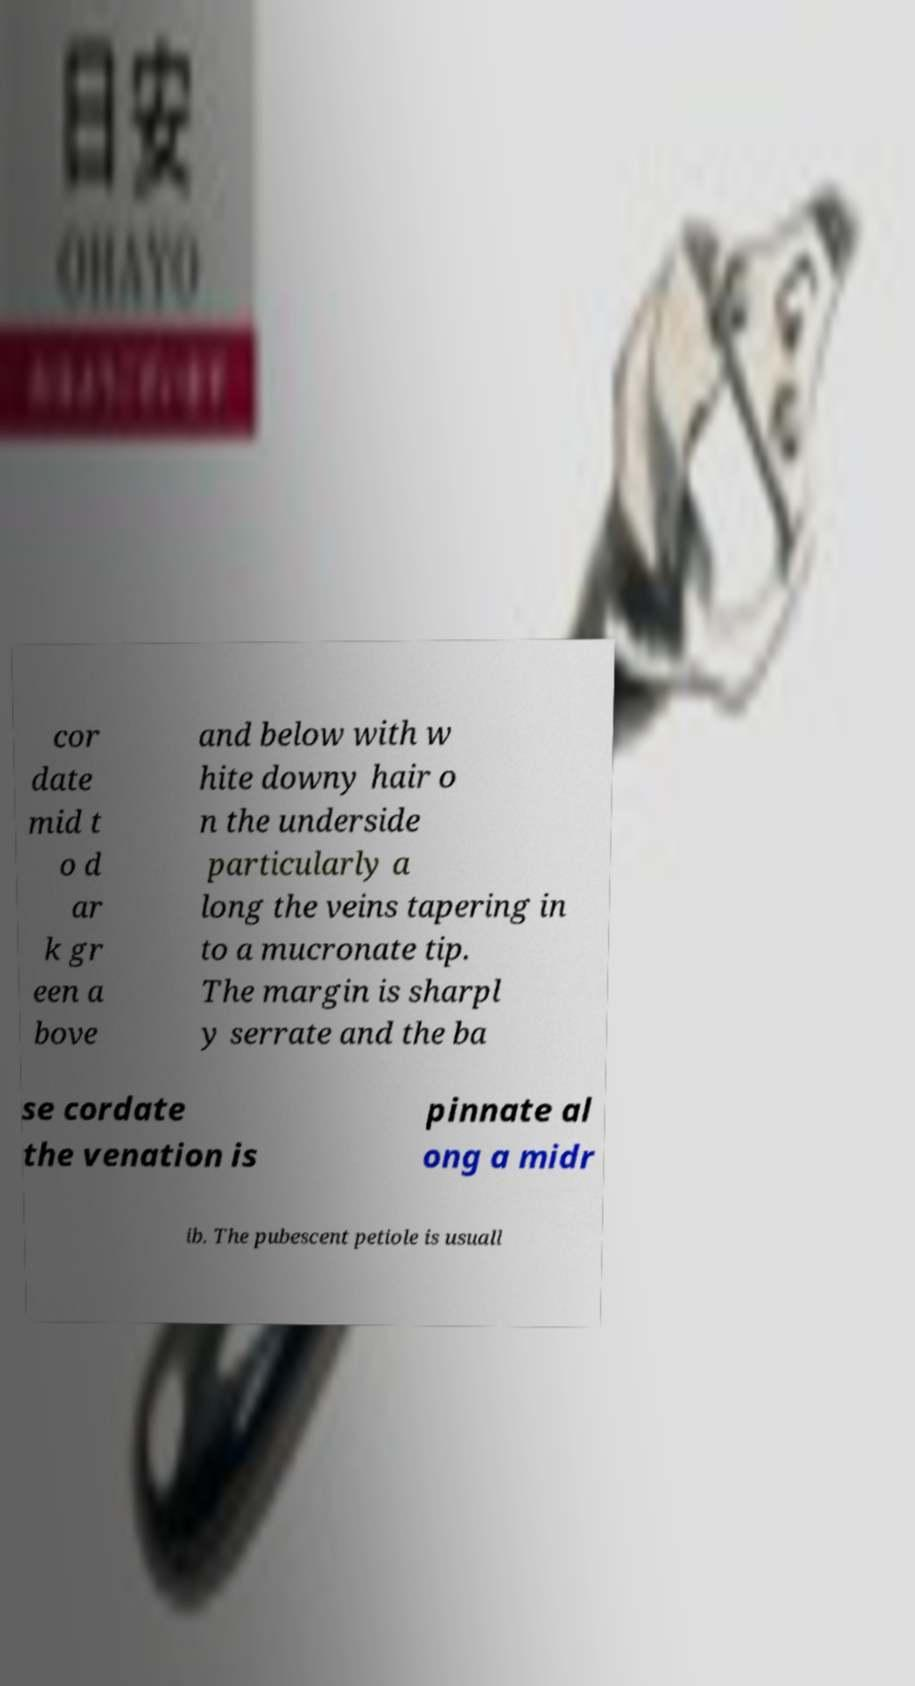Please read and relay the text visible in this image. What does it say? cor date mid t o d ar k gr een a bove and below with w hite downy hair o n the underside particularly a long the veins tapering in to a mucronate tip. The margin is sharpl y serrate and the ba se cordate the venation is pinnate al ong a midr ib. The pubescent petiole is usuall 